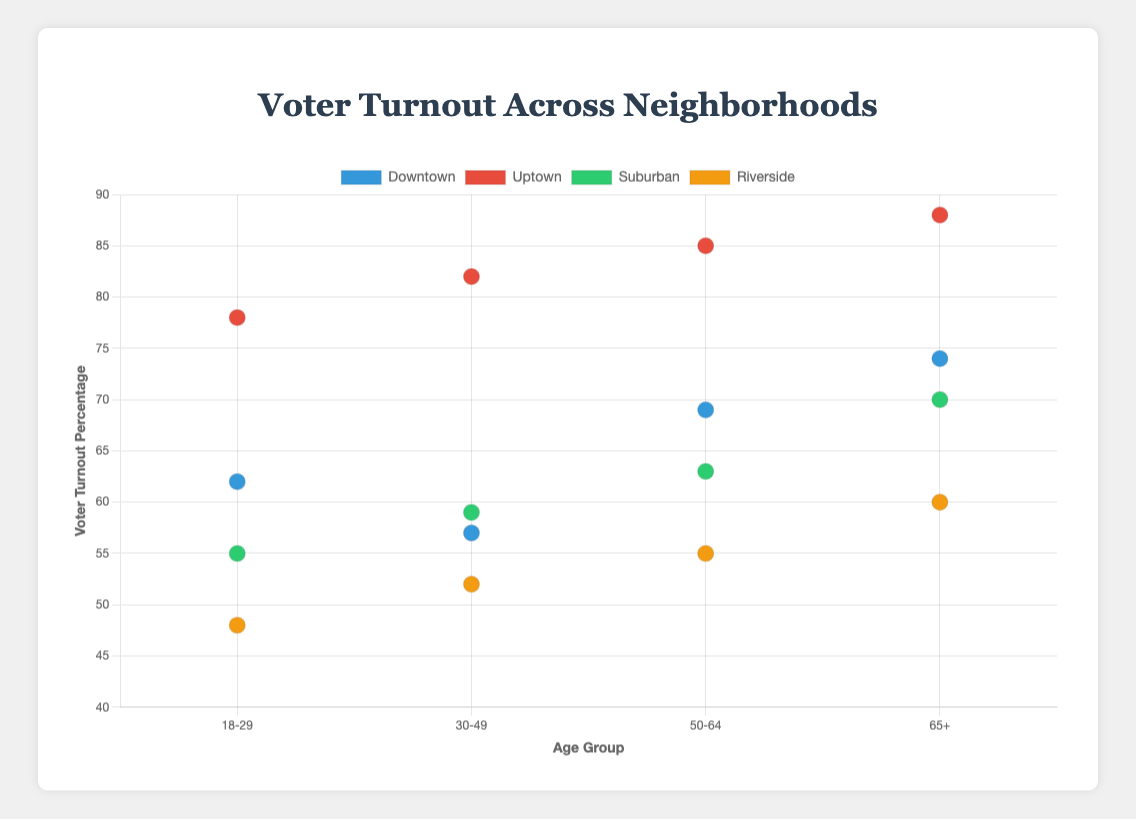What is the title of the figure? The title of the figure is usually presented at the top of the chart or plot. Here, it's clearly written.
Answer: Voter Turnout Across Neighborhoods What is the x-axis representing? The x-axis generally labels what is shown at the bottom of the chart. In this case, it represents age groups.
Answer: Age Group Which neighborhood has the highest voter turnout percentage for the age group 65+? We look at each neighborhood's data point for the age group 65+. The one with the highest y-coordinate here is Uptown, with an 88% voter turnout.
Answer: Uptown How does voter turnout change with age in Downtown? We can trace the data points of Downtown across different age groups (from left to right on the x-axis). The voter turnout percentages increase from 62% to 74% as age increases from 18-29 to 65+.
Answer: It increases Which neighborhood has the lowest voter turnout percentage for the age group 18-29? For the age group 18-29 (leftmost data points), the lowest y-coordinate is Riverside, with a 48% voter turnout.
Answer: Riverside What is the average voter turnout percentage for the Suburban neighborhood? To find the average, sum the voter turnout percentages for Suburban: 55 + 59 + 63 + 70 = 247, then divide by 4 (number of age groups): 247/4.
Answer: 61.75% What is the median voter turnout percentage for the neighborhood Riverside? The percentages are 48, 52, 55, 60. The median of four numbers is the average of the middle two numbers, (52+55)/2.
Answer: 53.5% Comparing Downtown and Uptown, which neighborhood has a greater overall voter turnout in the age group 30-49? Look at the data points for 30-49 age group in both Downtown (57%) and Uptown (82%). Uptown has the higher percentage.
Answer: Uptown Does voter turnout in Uptown increase with education level? Uptown has all data points with Bachelor's Degree and voter turnout increases from 78% to 88% as age increases. Since all voters here have Bachelor's Degree, we can infer turnout increases with age, not directly shown education level.
Answer: Not directly related 